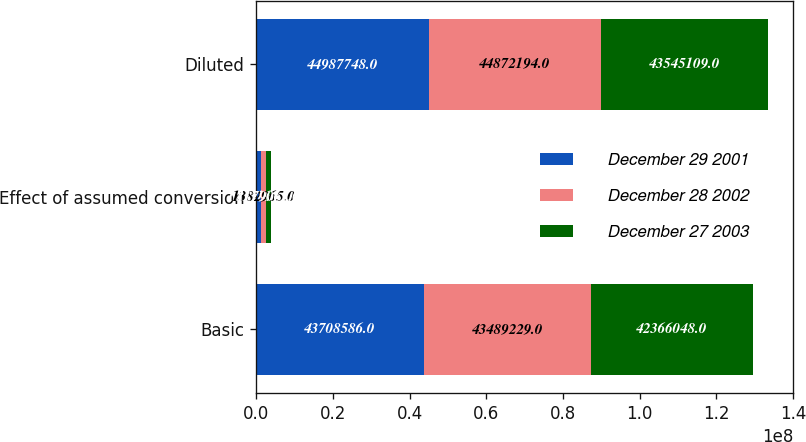Convert chart. <chart><loc_0><loc_0><loc_500><loc_500><stacked_bar_chart><ecel><fcel>Basic<fcel>Effect of assumed conversion<fcel>Diluted<nl><fcel>December 29 2001<fcel>4.37086e+07<fcel>1.27916e+06<fcel>4.49877e+07<nl><fcel>December 28 2002<fcel>4.34892e+07<fcel>1.38296e+06<fcel>4.48722e+07<nl><fcel>December 27 2003<fcel>4.2366e+07<fcel>1.17906e+06<fcel>4.35451e+07<nl></chart> 